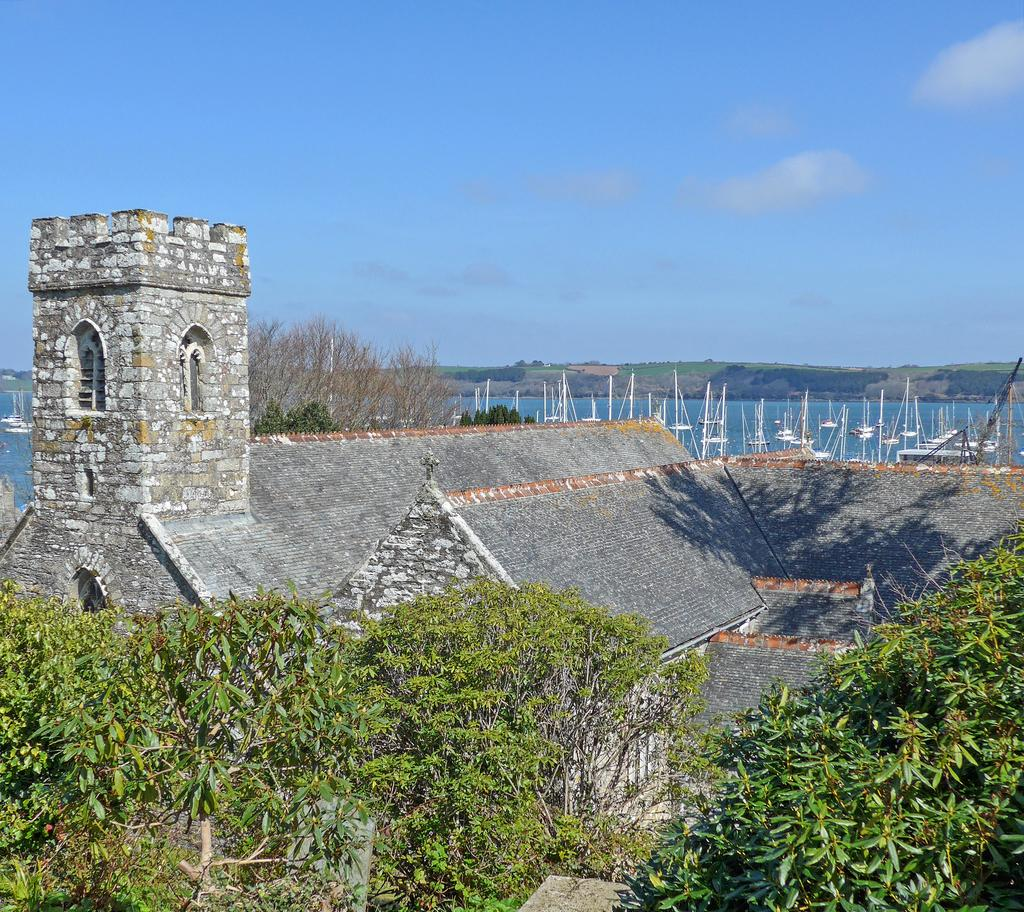What type of natural elements can be seen in the image? There are trees and mountains visible in the image. What type of man-made structure is present in the image? There is a building structure in the image. What is on the water surface in the image? There are boats on the water surface in the image. What is visible in the background of the image? The sky is visible in the background of the image. Where is the sofa located in the image? There is no sofa present in the image. What flavor of toothpaste is being used by the people in the image? There are no people or toothpaste present in the image. 